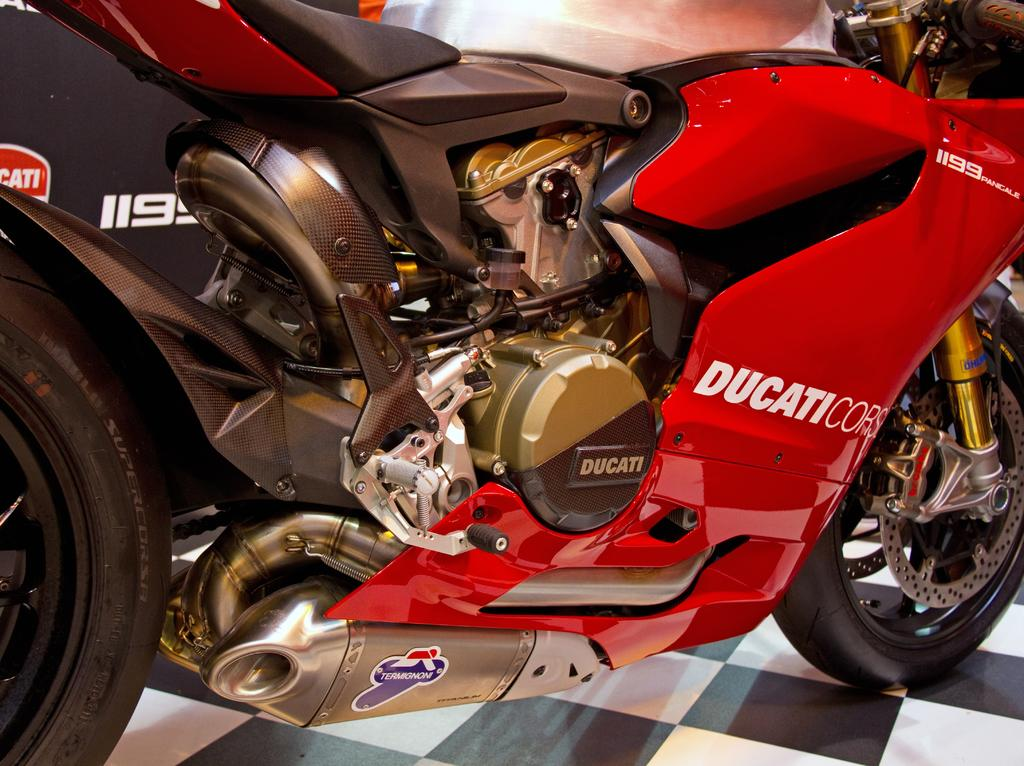What is the main object in the image? There is a bike in the image. What color is the bike? The bike is red in color. What is the surface beneath the bike? There is a floor at the bottom of the image. What type of rock is being discussed in the meeting in the image? There is no meeting or rock present in the image; it features a red bike and a floor. 